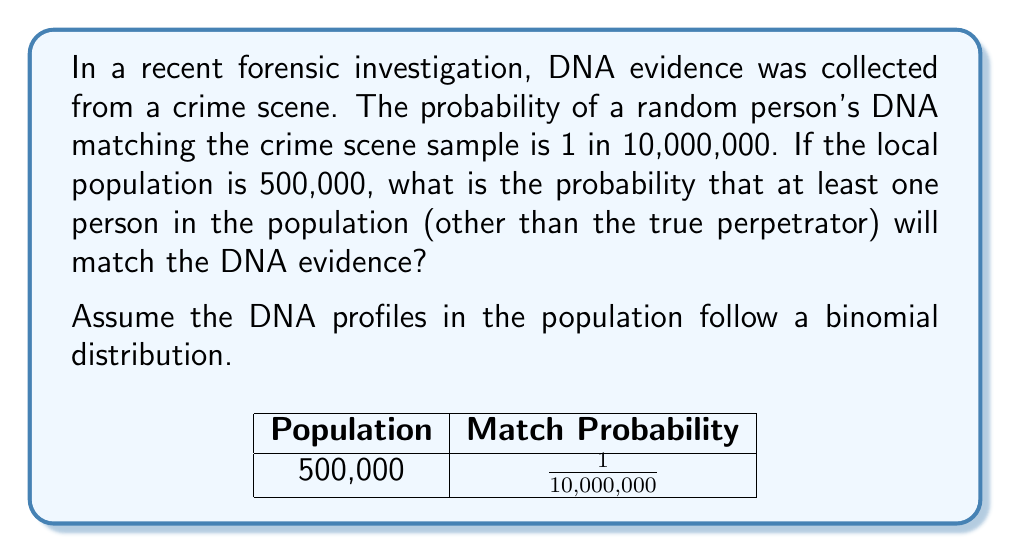Solve this math problem. Let's approach this step-by-step:

1) First, we need to calculate the probability of a single person not matching the DNA evidence:
   
   $p(\text{not matching}) = 1 - \frac{1}{10,000,000} = 0.9999999$

2) Now, we want to find the probability that all 500,000 people in the population do not match:
   
   $p(\text{all not matching}) = (0.9999999)^{500,000}$

3) We can calculate this using logarithms to avoid numerical issues:
   
   $\log(p(\text{all not matching})) = 500,000 \times \log(0.9999999) \approx -0.05$
   
   $p(\text{all not matching}) = e^{-0.05} \approx 0.9512$

4) The probability that at least one person matches is the complement of this probability:
   
   $p(\text{at least one match}) = 1 - p(\text{all not matching}) \approx 1 - 0.9512 = 0.0488$

5) Converting to a percentage:
   
   $0.0488 \times 100\% = 4.88\%$

Therefore, there is approximately a 4.88% chance that at least one person in the population (other than the true perpetrator) will match the DNA evidence.
Answer: 4.88% 